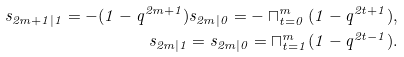<formula> <loc_0><loc_0><loc_500><loc_500>s _ { 2 m + 1 | 1 } = - ( 1 - q ^ { 2 m + 1 } ) s _ { 2 m | 0 } = - \sqcap ^ { m } _ { t = 0 } ( 1 - q ^ { 2 t + 1 } ) , \\ s _ { 2 m | 1 } = s _ { 2 m | 0 } = \sqcap ^ { m } _ { t = 1 } ( 1 - q ^ { 2 t - 1 } ) .</formula> 